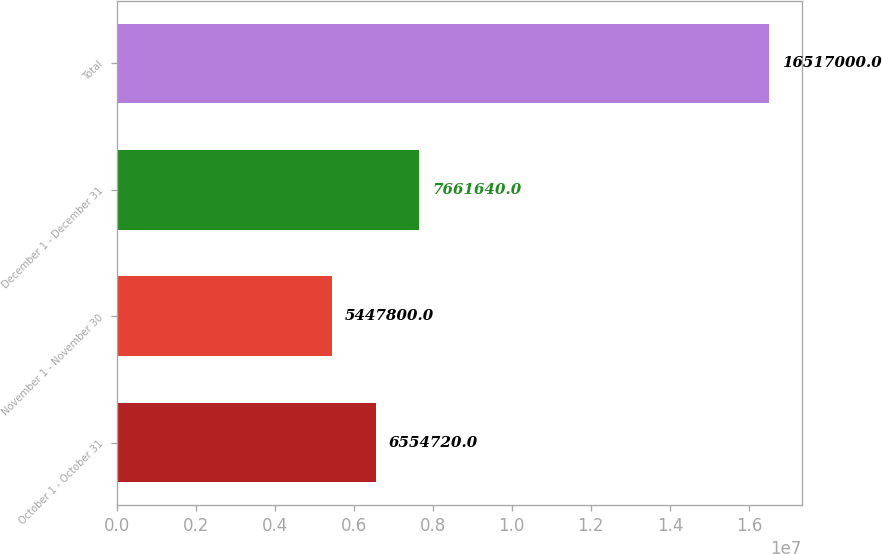<chart> <loc_0><loc_0><loc_500><loc_500><bar_chart><fcel>October 1 - October 31<fcel>November 1 - November 30<fcel>December 1 - December 31<fcel>Total<nl><fcel>6.55472e+06<fcel>5.4478e+06<fcel>7.66164e+06<fcel>1.6517e+07<nl></chart> 